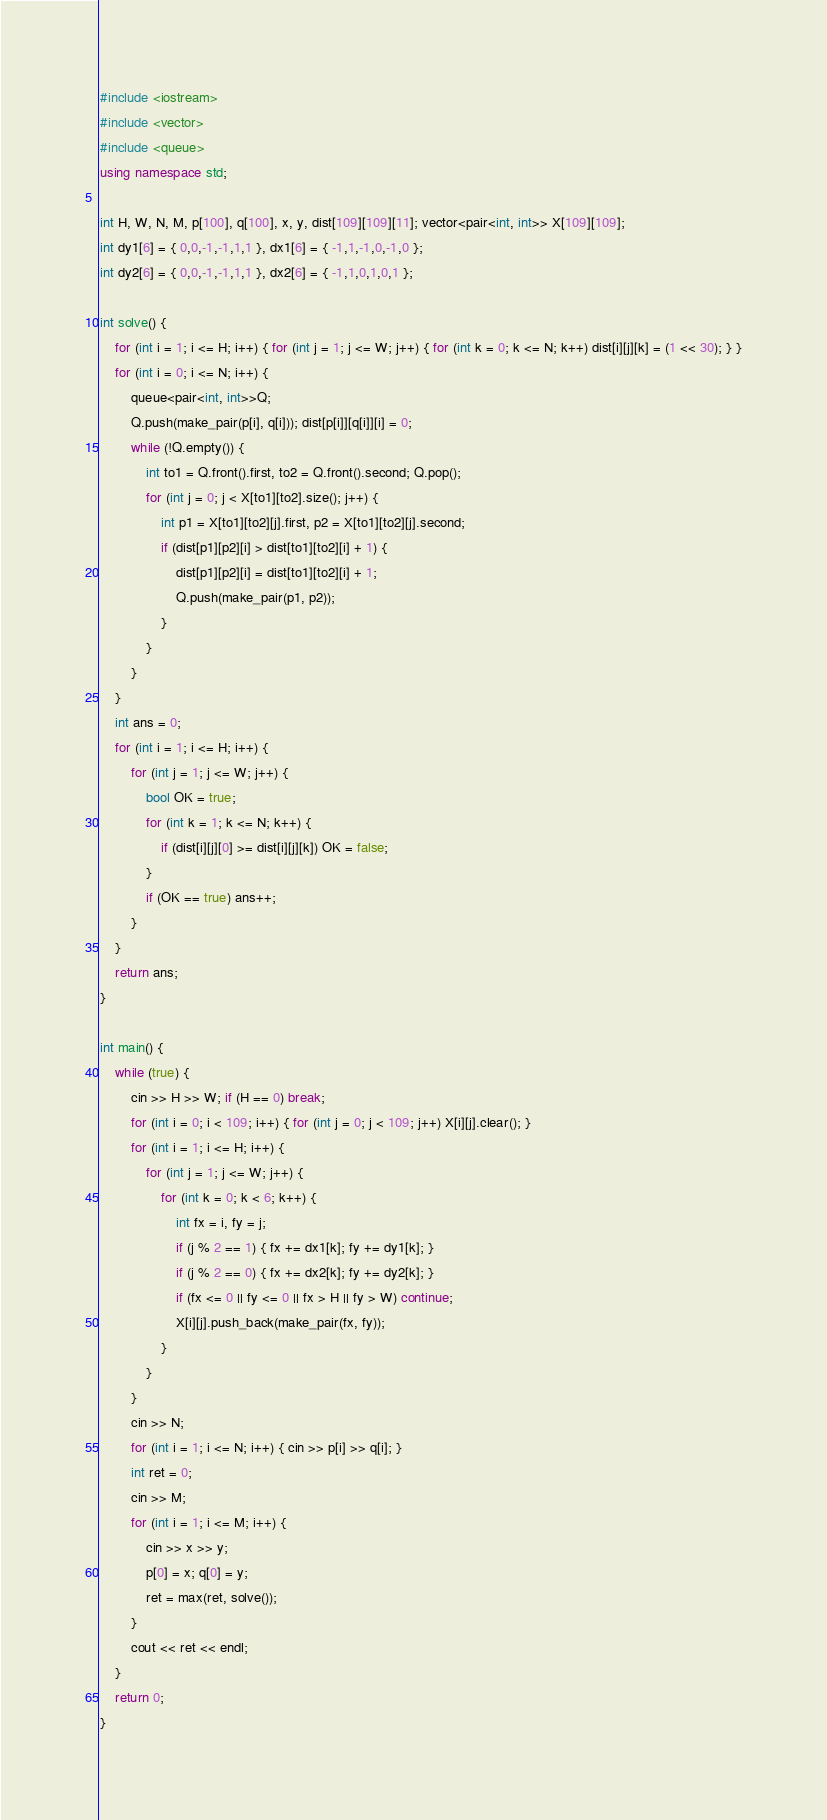<code> <loc_0><loc_0><loc_500><loc_500><_C++_>#include <iostream>
#include <vector>
#include <queue>
using namespace std;

int H, W, N, M, p[100], q[100], x, y, dist[109][109][11]; vector<pair<int, int>> X[109][109];
int dy1[6] = { 0,0,-1,-1,1,1 }, dx1[6] = { -1,1,-1,0,-1,0 };
int dy2[6] = { 0,0,-1,-1,1,1 }, dx2[6] = { -1,1,0,1,0,1 };

int solve() {
	for (int i = 1; i <= H; i++) { for (int j = 1; j <= W; j++) { for (int k = 0; k <= N; k++) dist[i][j][k] = (1 << 30); } }
	for (int i = 0; i <= N; i++) {
		queue<pair<int, int>>Q;
		Q.push(make_pair(p[i], q[i])); dist[p[i]][q[i]][i] = 0;
		while (!Q.empty()) {
			int to1 = Q.front().first, to2 = Q.front().second; Q.pop();
			for (int j = 0; j < X[to1][to2].size(); j++) {
				int p1 = X[to1][to2][j].first, p2 = X[to1][to2][j].second;
				if (dist[p1][p2][i] > dist[to1][to2][i] + 1) {
					dist[p1][p2][i] = dist[to1][to2][i] + 1;
					Q.push(make_pair(p1, p2));
				}
			}
		}
	}
	int ans = 0;
	for (int i = 1; i <= H; i++) {
		for (int j = 1; j <= W; j++) {
			bool OK = true;
			for (int k = 1; k <= N; k++) {
				if (dist[i][j][0] >= dist[i][j][k]) OK = false;
			}
			if (OK == true) ans++;
		}
	}
	return ans;
}

int main() {
	while (true) {
		cin >> H >> W; if (H == 0) break;
		for (int i = 0; i < 109; i++) { for (int j = 0; j < 109; j++) X[i][j].clear(); }
		for (int i = 1; i <= H; i++) {
			for (int j = 1; j <= W; j++) {
				for (int k = 0; k < 6; k++) {
					int fx = i, fy = j;
					if (j % 2 == 1) { fx += dx1[k]; fy += dy1[k]; }
					if (j % 2 == 0) { fx += dx2[k]; fy += dy2[k]; }
					if (fx <= 0 || fy <= 0 || fx > H || fy > W) continue;
					X[i][j].push_back(make_pair(fx, fy));
				}
			}
		}
		cin >> N;
		for (int i = 1; i <= N; i++) { cin >> p[i] >> q[i]; }
		int ret = 0;
		cin >> M;
		for (int i = 1; i <= M; i++) {
			cin >> x >> y;
			p[0] = x; q[0] = y;
			ret = max(ret, solve());
		}
		cout << ret << endl;
	}
	return 0;
}
</code> 